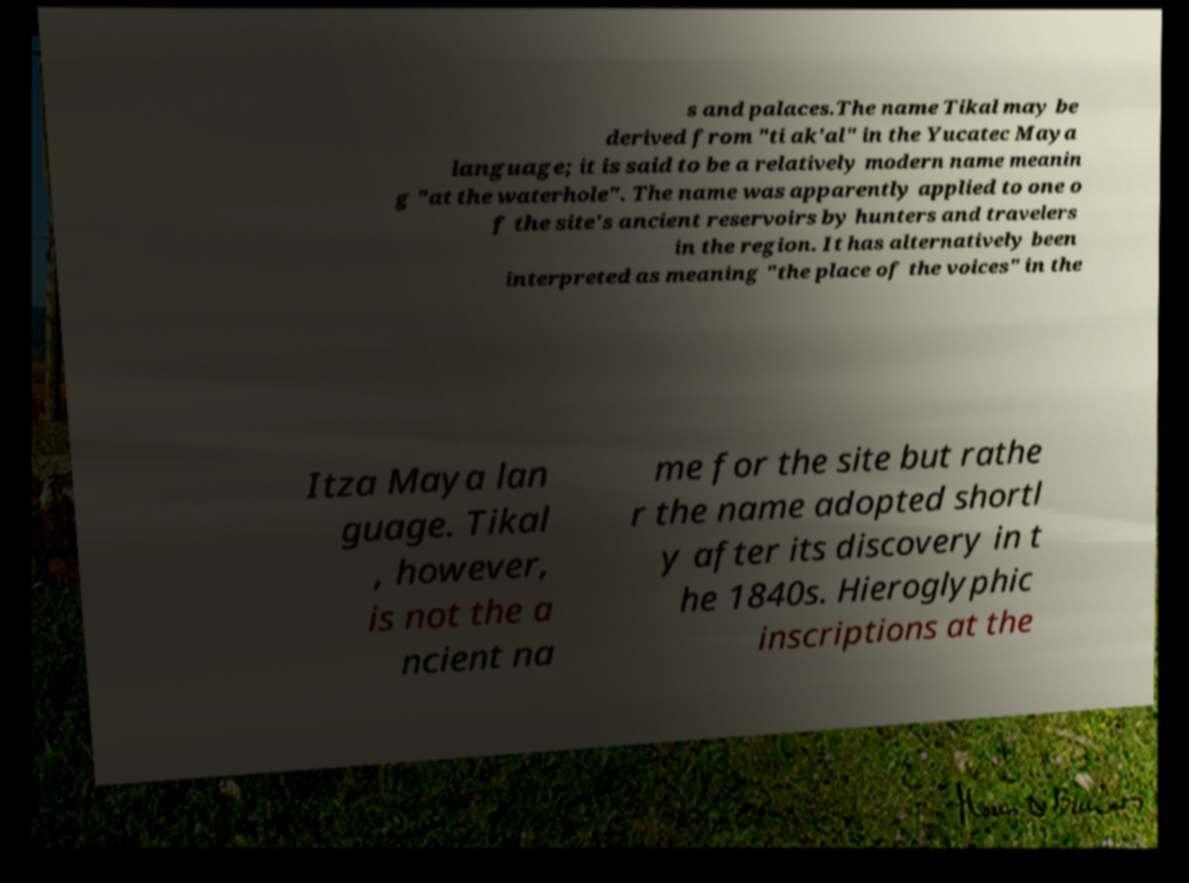Please identify and transcribe the text found in this image. s and palaces.The name Tikal may be derived from "ti ak'al" in the Yucatec Maya language; it is said to be a relatively modern name meanin g "at the waterhole". The name was apparently applied to one o f the site's ancient reservoirs by hunters and travelers in the region. It has alternatively been interpreted as meaning "the place of the voices" in the Itza Maya lan guage. Tikal , however, is not the a ncient na me for the site but rathe r the name adopted shortl y after its discovery in t he 1840s. Hieroglyphic inscriptions at the 